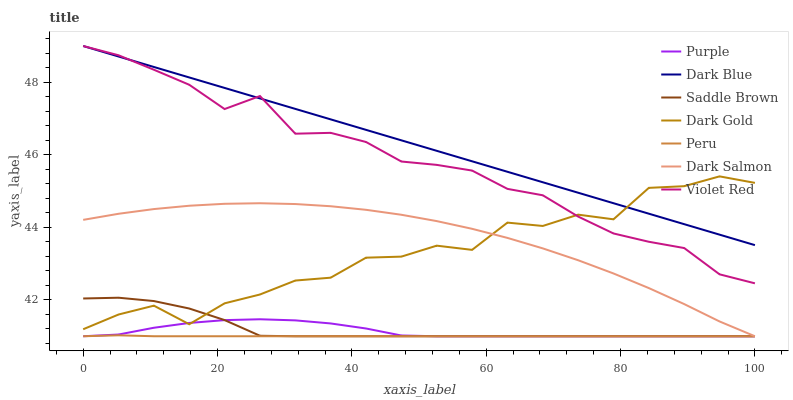Does Peru have the minimum area under the curve?
Answer yes or no. Yes. Does Dark Blue have the maximum area under the curve?
Answer yes or no. Yes. Does Dark Gold have the minimum area under the curve?
Answer yes or no. No. Does Dark Gold have the maximum area under the curve?
Answer yes or no. No. Is Dark Blue the smoothest?
Answer yes or no. Yes. Is Dark Gold the roughest?
Answer yes or no. Yes. Is Purple the smoothest?
Answer yes or no. No. Is Purple the roughest?
Answer yes or no. No. Does Purple have the lowest value?
Answer yes or no. Yes. Does Dark Gold have the lowest value?
Answer yes or no. No. Does Dark Blue have the highest value?
Answer yes or no. Yes. Does Dark Gold have the highest value?
Answer yes or no. No. Is Dark Salmon less than Dark Blue?
Answer yes or no. Yes. Is Violet Red greater than Dark Salmon?
Answer yes or no. Yes. Does Dark Salmon intersect Dark Gold?
Answer yes or no. Yes. Is Dark Salmon less than Dark Gold?
Answer yes or no. No. Is Dark Salmon greater than Dark Gold?
Answer yes or no. No. Does Dark Salmon intersect Dark Blue?
Answer yes or no. No. 